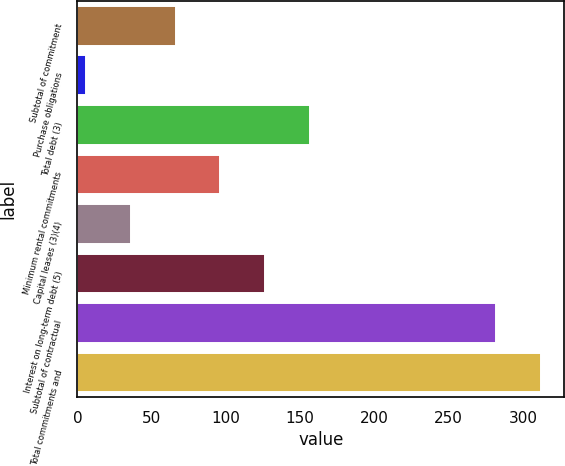Convert chart to OTSL. <chart><loc_0><loc_0><loc_500><loc_500><bar_chart><fcel>Subtotal of commitment<fcel>Purchase obligations<fcel>Total debt (3)<fcel>Minimum rental commitments<fcel>Capital leases (3)(4)<fcel>Interest on long-term debt (5)<fcel>Subtotal of contractual<fcel>Total commitments and<nl><fcel>66.2<fcel>6<fcel>156.5<fcel>96.3<fcel>36.1<fcel>126.4<fcel>282<fcel>312.1<nl></chart> 